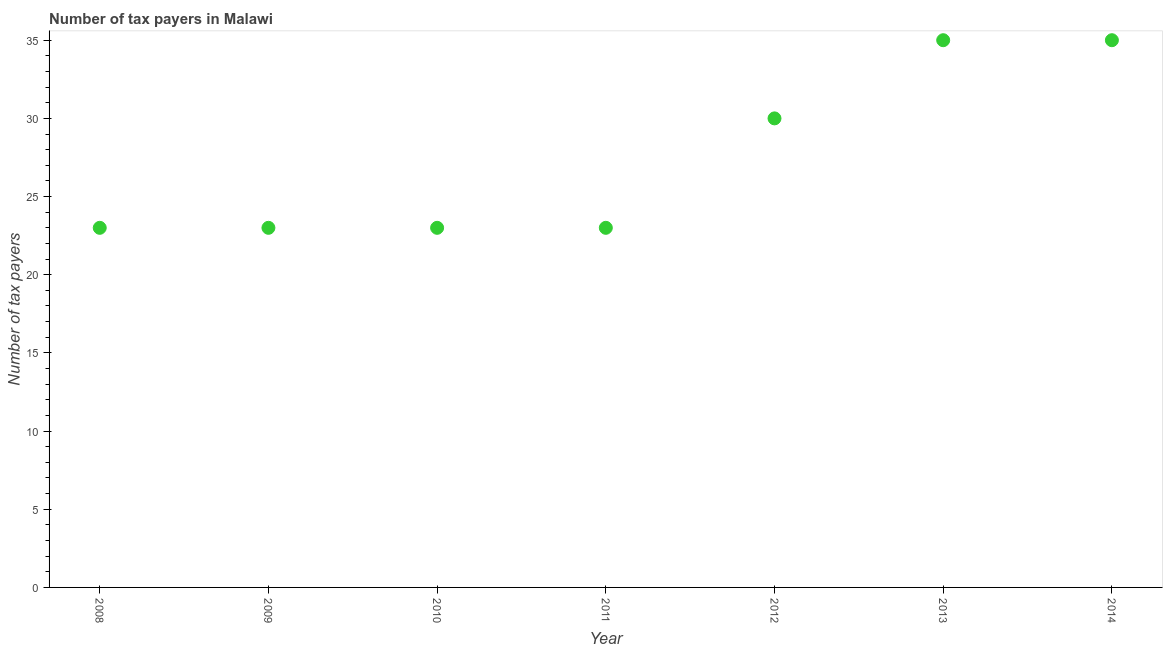What is the number of tax payers in 2008?
Offer a very short reply. 23. Across all years, what is the maximum number of tax payers?
Your response must be concise. 35. Across all years, what is the minimum number of tax payers?
Provide a succinct answer. 23. What is the sum of the number of tax payers?
Your response must be concise. 192. What is the difference between the number of tax payers in 2009 and 2014?
Make the answer very short. -12. What is the average number of tax payers per year?
Ensure brevity in your answer.  27.43. Do a majority of the years between 2009 and 2010 (inclusive) have number of tax payers greater than 14 ?
Offer a very short reply. Yes. What is the ratio of the number of tax payers in 2011 to that in 2013?
Provide a succinct answer. 0.66. Is the number of tax payers in 2009 less than that in 2013?
Ensure brevity in your answer.  Yes. Is the difference between the number of tax payers in 2008 and 2011 greater than the difference between any two years?
Ensure brevity in your answer.  No. What is the difference between the highest and the second highest number of tax payers?
Your answer should be very brief. 0. Is the sum of the number of tax payers in 2012 and 2014 greater than the maximum number of tax payers across all years?
Offer a terse response. Yes. What is the difference between the highest and the lowest number of tax payers?
Ensure brevity in your answer.  12. In how many years, is the number of tax payers greater than the average number of tax payers taken over all years?
Ensure brevity in your answer.  3. Does the number of tax payers monotonically increase over the years?
Give a very brief answer. No. Does the graph contain any zero values?
Your answer should be very brief. No. What is the title of the graph?
Make the answer very short. Number of tax payers in Malawi. What is the label or title of the Y-axis?
Provide a succinct answer. Number of tax payers. What is the Number of tax payers in 2008?
Ensure brevity in your answer.  23. What is the Number of tax payers in 2011?
Your answer should be compact. 23. What is the Number of tax payers in 2012?
Make the answer very short. 30. What is the Number of tax payers in 2013?
Provide a succinct answer. 35. What is the difference between the Number of tax payers in 2008 and 2009?
Your response must be concise. 0. What is the difference between the Number of tax payers in 2008 and 2012?
Offer a terse response. -7. What is the difference between the Number of tax payers in 2009 and 2010?
Ensure brevity in your answer.  0. What is the difference between the Number of tax payers in 2009 and 2011?
Offer a very short reply. 0. What is the difference between the Number of tax payers in 2009 and 2013?
Make the answer very short. -12. What is the difference between the Number of tax payers in 2009 and 2014?
Offer a terse response. -12. What is the difference between the Number of tax payers in 2010 and 2012?
Ensure brevity in your answer.  -7. What is the difference between the Number of tax payers in 2010 and 2013?
Offer a very short reply. -12. What is the difference between the Number of tax payers in 2010 and 2014?
Make the answer very short. -12. What is the difference between the Number of tax payers in 2011 and 2012?
Ensure brevity in your answer.  -7. What is the difference between the Number of tax payers in 2011 and 2014?
Provide a succinct answer. -12. What is the ratio of the Number of tax payers in 2008 to that in 2012?
Offer a very short reply. 0.77. What is the ratio of the Number of tax payers in 2008 to that in 2013?
Offer a very short reply. 0.66. What is the ratio of the Number of tax payers in 2008 to that in 2014?
Offer a terse response. 0.66. What is the ratio of the Number of tax payers in 2009 to that in 2010?
Your response must be concise. 1. What is the ratio of the Number of tax payers in 2009 to that in 2012?
Your response must be concise. 0.77. What is the ratio of the Number of tax payers in 2009 to that in 2013?
Offer a terse response. 0.66. What is the ratio of the Number of tax payers in 2009 to that in 2014?
Give a very brief answer. 0.66. What is the ratio of the Number of tax payers in 2010 to that in 2012?
Give a very brief answer. 0.77. What is the ratio of the Number of tax payers in 2010 to that in 2013?
Offer a terse response. 0.66. What is the ratio of the Number of tax payers in 2010 to that in 2014?
Your response must be concise. 0.66. What is the ratio of the Number of tax payers in 2011 to that in 2012?
Your response must be concise. 0.77. What is the ratio of the Number of tax payers in 2011 to that in 2013?
Keep it short and to the point. 0.66. What is the ratio of the Number of tax payers in 2011 to that in 2014?
Offer a very short reply. 0.66. What is the ratio of the Number of tax payers in 2012 to that in 2013?
Keep it short and to the point. 0.86. What is the ratio of the Number of tax payers in 2012 to that in 2014?
Provide a succinct answer. 0.86. What is the ratio of the Number of tax payers in 2013 to that in 2014?
Your answer should be very brief. 1. 